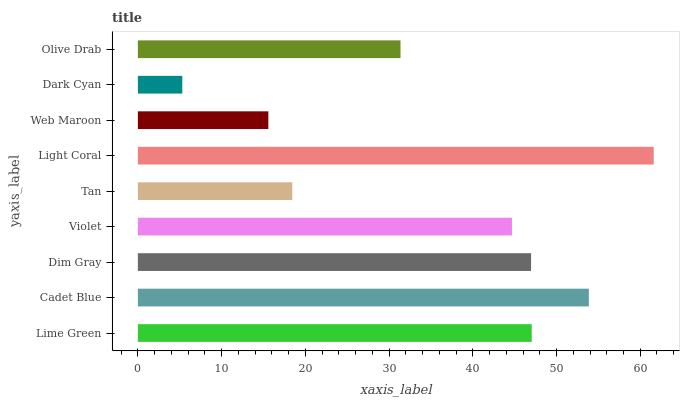Is Dark Cyan the minimum?
Answer yes or no. Yes. Is Light Coral the maximum?
Answer yes or no. Yes. Is Cadet Blue the minimum?
Answer yes or no. No. Is Cadet Blue the maximum?
Answer yes or no. No. Is Cadet Blue greater than Lime Green?
Answer yes or no. Yes. Is Lime Green less than Cadet Blue?
Answer yes or no. Yes. Is Lime Green greater than Cadet Blue?
Answer yes or no. No. Is Cadet Blue less than Lime Green?
Answer yes or no. No. Is Violet the high median?
Answer yes or no. Yes. Is Violet the low median?
Answer yes or no. Yes. Is Web Maroon the high median?
Answer yes or no. No. Is Light Coral the low median?
Answer yes or no. No. 